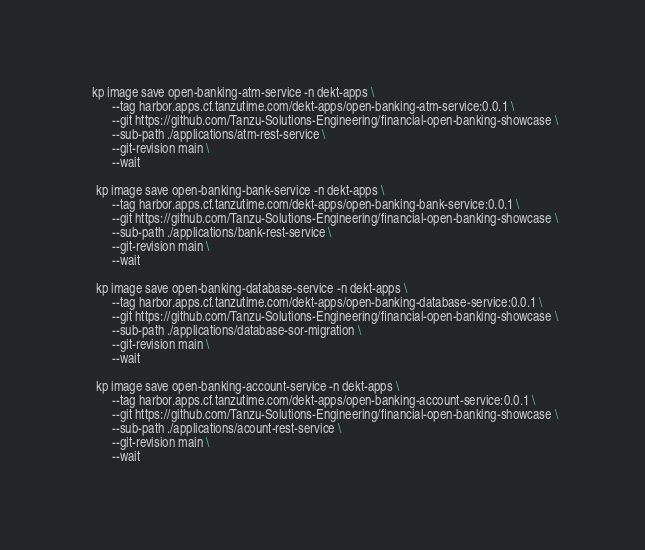Convert code to text. <code><loc_0><loc_0><loc_500><loc_500><_Bash_>  kp image save open-banking-atm-service -n dekt-apps \
        --tag harbor.apps.cf.tanzutime.com/dekt-apps/open-banking-atm-service:0.0.1 \
        --git https://github.com/Tanzu-Solutions-Engineering/financial-open-banking-showcase \
        --sub-path ./applications/atm-rest-service \
        --git-revision main \
        --wait

   kp image save open-banking-bank-service -n dekt-apps \
        --tag harbor.apps.cf.tanzutime.com/dekt-apps/open-banking-bank-service:0.0.1 \
        --git https://github.com/Tanzu-Solutions-Engineering/financial-open-banking-showcase \
        --sub-path ./applications/bank-rest-service \
        --git-revision main \
        --wait

   kp image save open-banking-database-service -n dekt-apps \
        --tag harbor.apps.cf.tanzutime.com/dekt-apps/open-banking-database-service:0.0.1 \
        --git https://github.com/Tanzu-Solutions-Engineering/financial-open-banking-showcase \
        --sub-path ./applications/database-sor-migration \
        --git-revision main \
        --wait

   kp image save open-banking-account-service -n dekt-apps \
        --tag harbor.apps.cf.tanzutime.com/dekt-apps/open-banking-account-service:0.0.1 \
        --git https://github.com/Tanzu-Solutions-Engineering/financial-open-banking-showcase \
        --sub-path ./applications/acount-rest-service \
        --git-revision main \
        --wait
</code> 